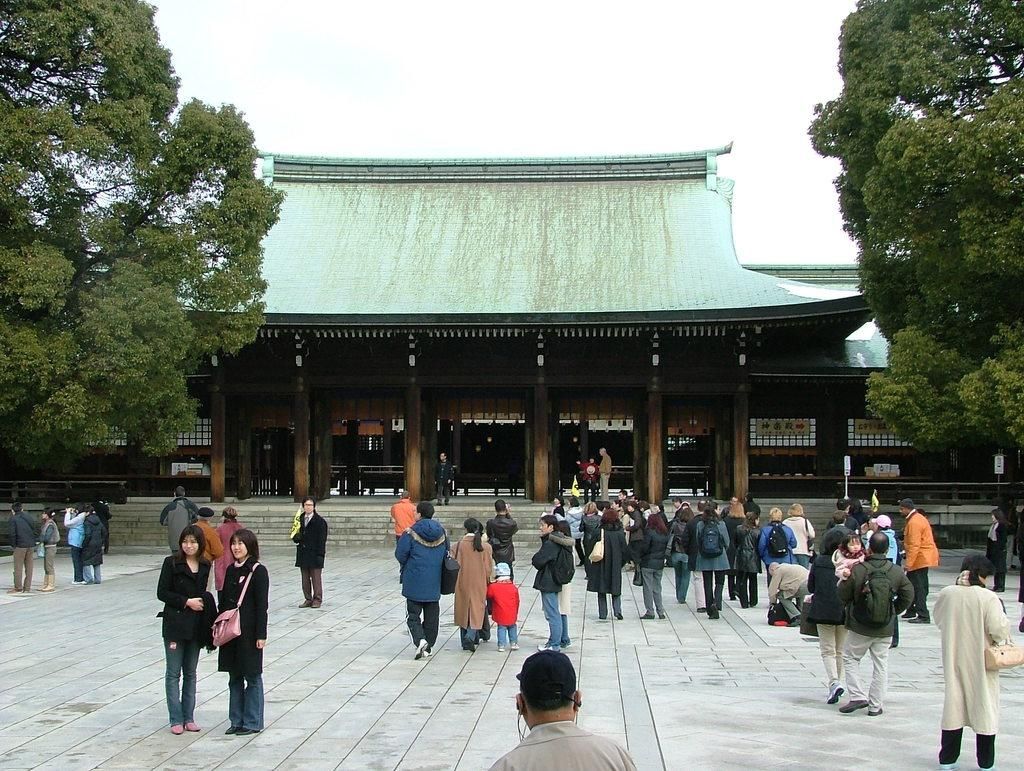What is located at the bottom of the image? There are people, stairs, and a path at the bottom of the image. What can be seen in the background of the image? There is a house, railings, pillars, poles, boards, trees, people, and the sky visible in the background of the image. What time is displayed on the clock in the image? There is no clock present in the image. What is the texture of the chin of the person in the image? There is no chin visible in the image, as the people are not shown in close-up detail. 